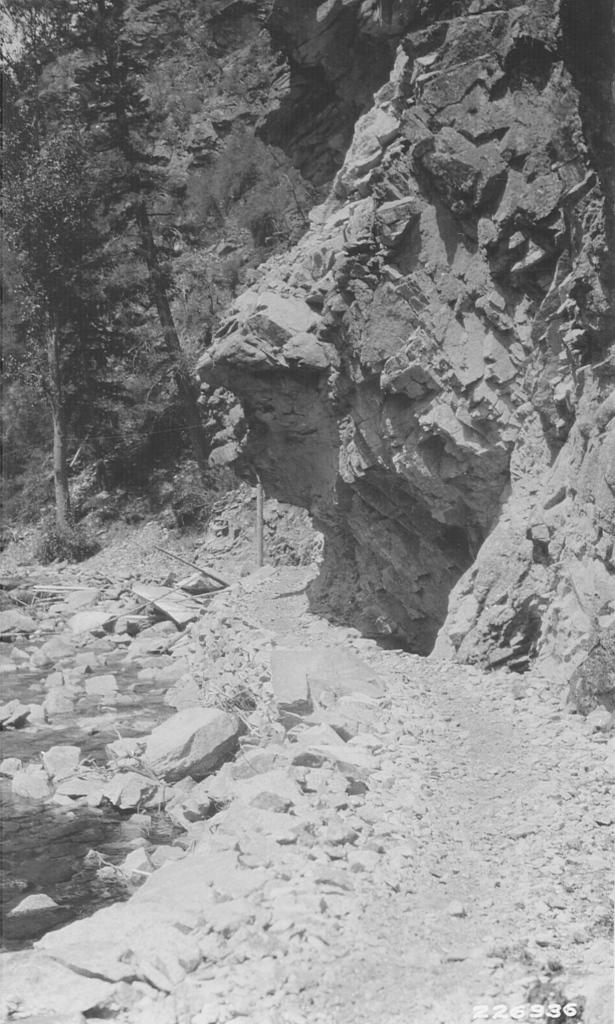What type of natural elements can be seen in the image? There are rocks and trees in the image. Can you describe the text on the right side of the image? Unfortunately, the provided facts do not give any information about the text on the right side of the image. What type of landscape is depicted in the image? The image features a natural landscape with rocks and trees. What grade is the ornament in the image? There is no ornament present in the image, so it cannot be assigned a grade. 